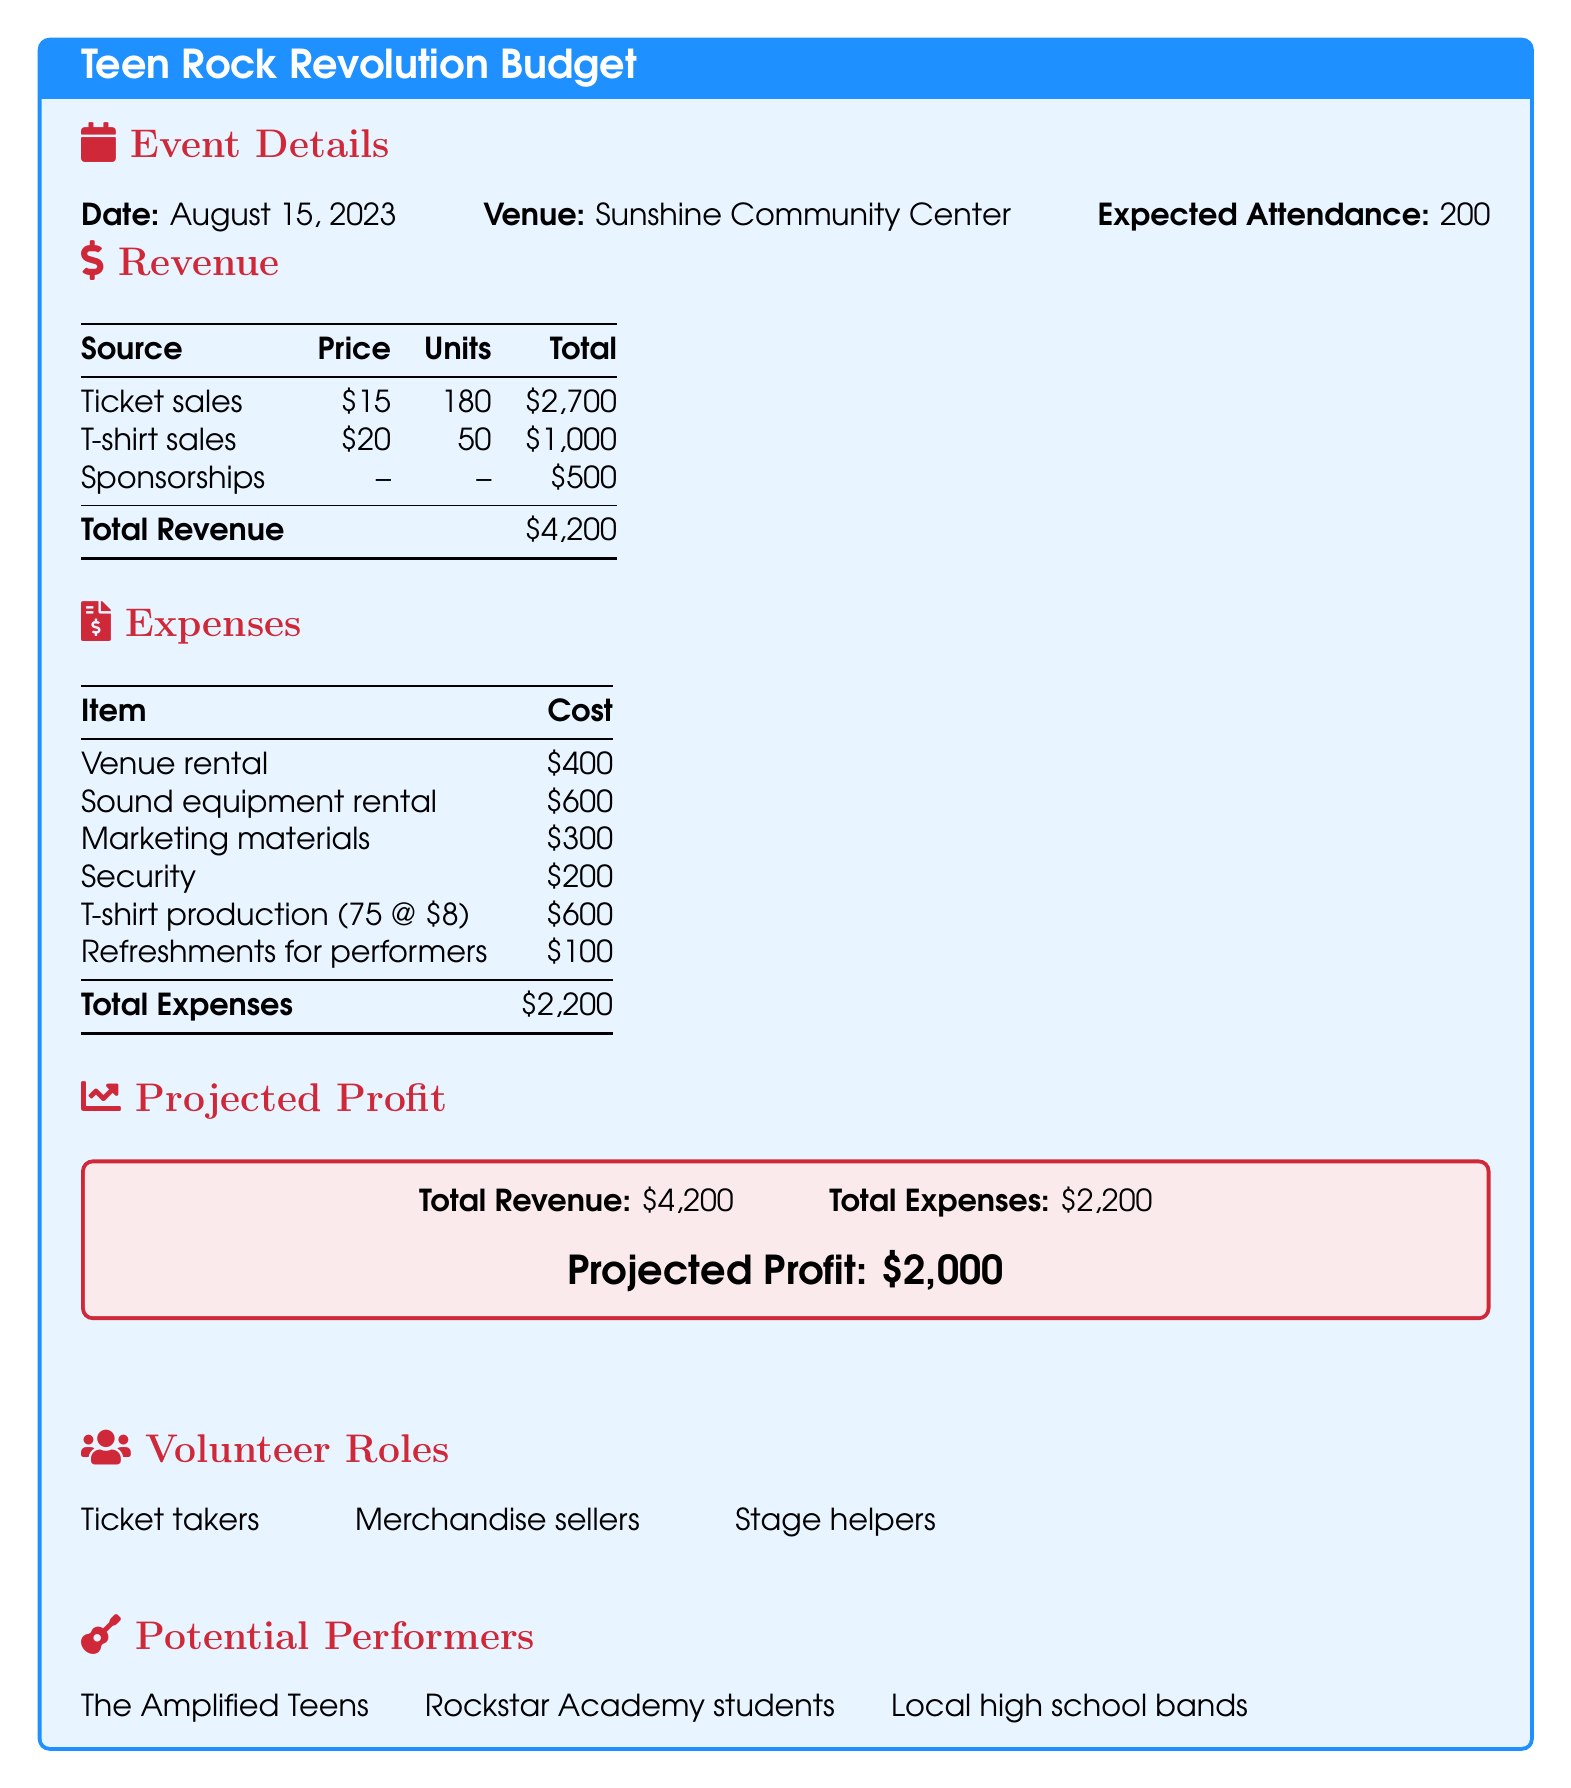What is the date of the event? The date of the event is specifically mentioned in the document under event details.
Answer: August 15, 2023 What is the expected attendance? The expected attendance is included in the event details as the number of attendees projected for the concert.
Answer: 200 What is the total revenue? The total revenue is calculated by adding all sources of revenue listed in the document, which includes ticket sales, T-shirt sales, and sponsorships.
Answer: $4,200 What are the expenses for sound equipment rental? The cost for sound equipment rental is listed separately in the expenses section of the document.
Answer: $600 How much is spent on marketing materials? The amount spent on marketing materials can be found in the expenses table, detailing each item cost.
Answer: $300 How much profit is projected from the concert? The projected profit is calculated by subtracting total expenses from total revenue, which is also stated in the document.
Answer: $2,000 Who are the potential performers mentioned? The potential performers are explicitly listed in the document under a specific section for performers.
Answer: The Amplified Teens, Rockstar Academy students, Local high school bands What is the cost of venue rental? The cost for venue rental is specified in the expenses table as a distinct line item.
Answer: $400 What volunteer roles are mentioned? Various volunteer roles are listed in the document, outlining responsibilities needed for the event.
Answer: Ticket takers, Merchandise sellers, Stage helpers 